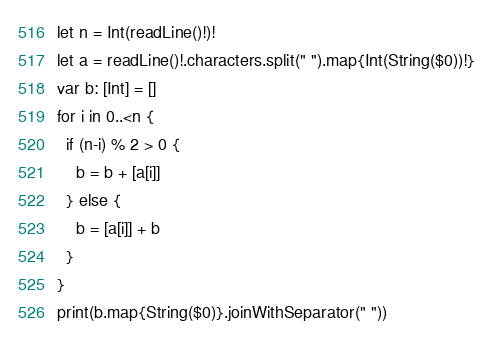<code> <loc_0><loc_0><loc_500><loc_500><_Swift_>let n = Int(readLine()!)!
let a = readLine()!.characters.split(" ").map{Int(String($0))!}
var b: [Int] = []
for i in 0..<n {
  if (n-i) % 2 > 0 {
    b = b + [a[i]]
  } else {
    b = [a[i]] + b
  }
}
print(b.map{String($0)}.joinWithSeparator(" "))</code> 